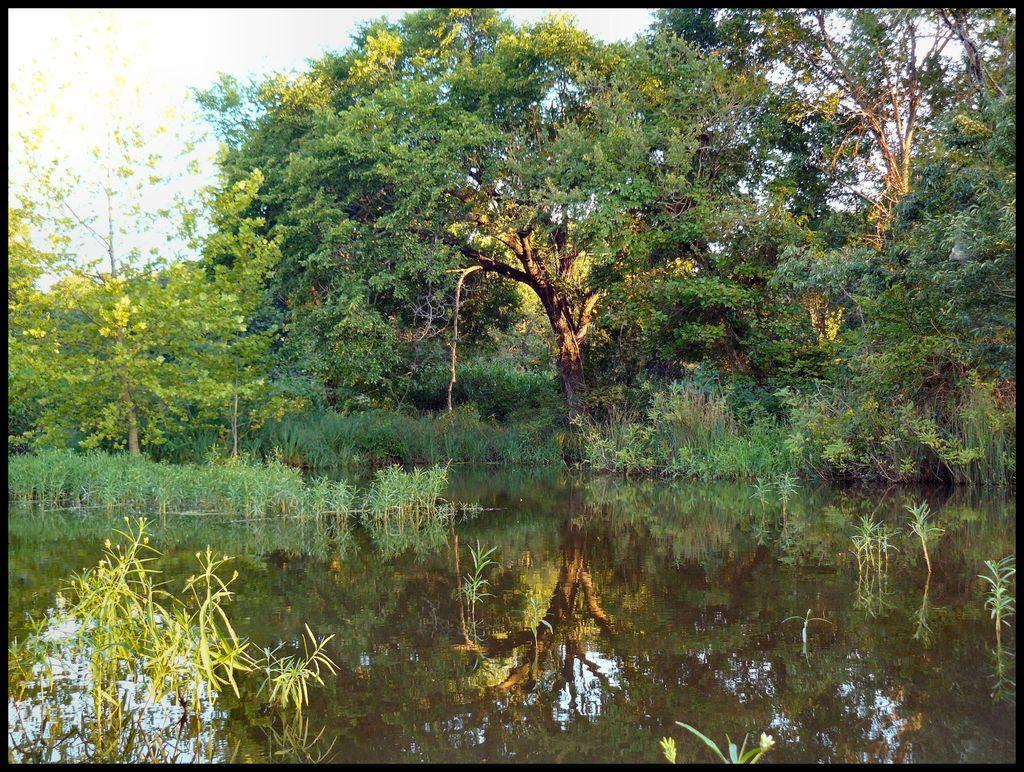In one or two sentences, can you explain what this image depicts? This image consists of water. In the background, there are many trees along with plants. It looks like it is clicked near a pond. At the top, there is sky. 